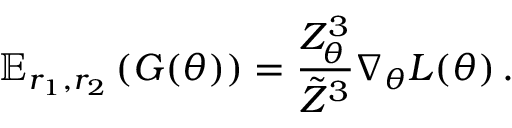<formula> <loc_0><loc_0><loc_500><loc_500>\mathbb { E } _ { r _ { 1 } , r _ { 2 } } \left ( G ( \theta ) \right ) = \frac { Z _ { \theta } ^ { 3 } } { \tilde { Z } ^ { 3 } } \nabla _ { \theta } L ( \theta ) \, .</formula> 